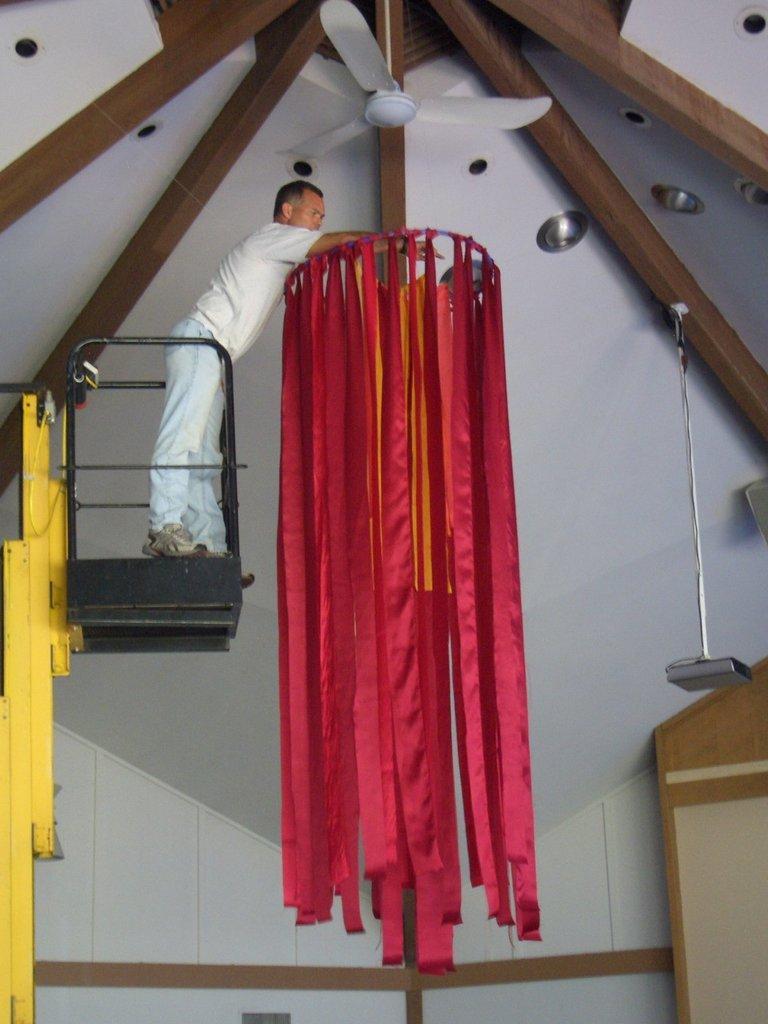Please provide a concise description of this image. This picture seems to be clicked inside the hall. On the left we can see a person standing on a metal object and we can see the red color ribbons hanging on an object. At the top we can see the wooden planks and the ceiling fan and we can see the ceiling lights and many other objects. 